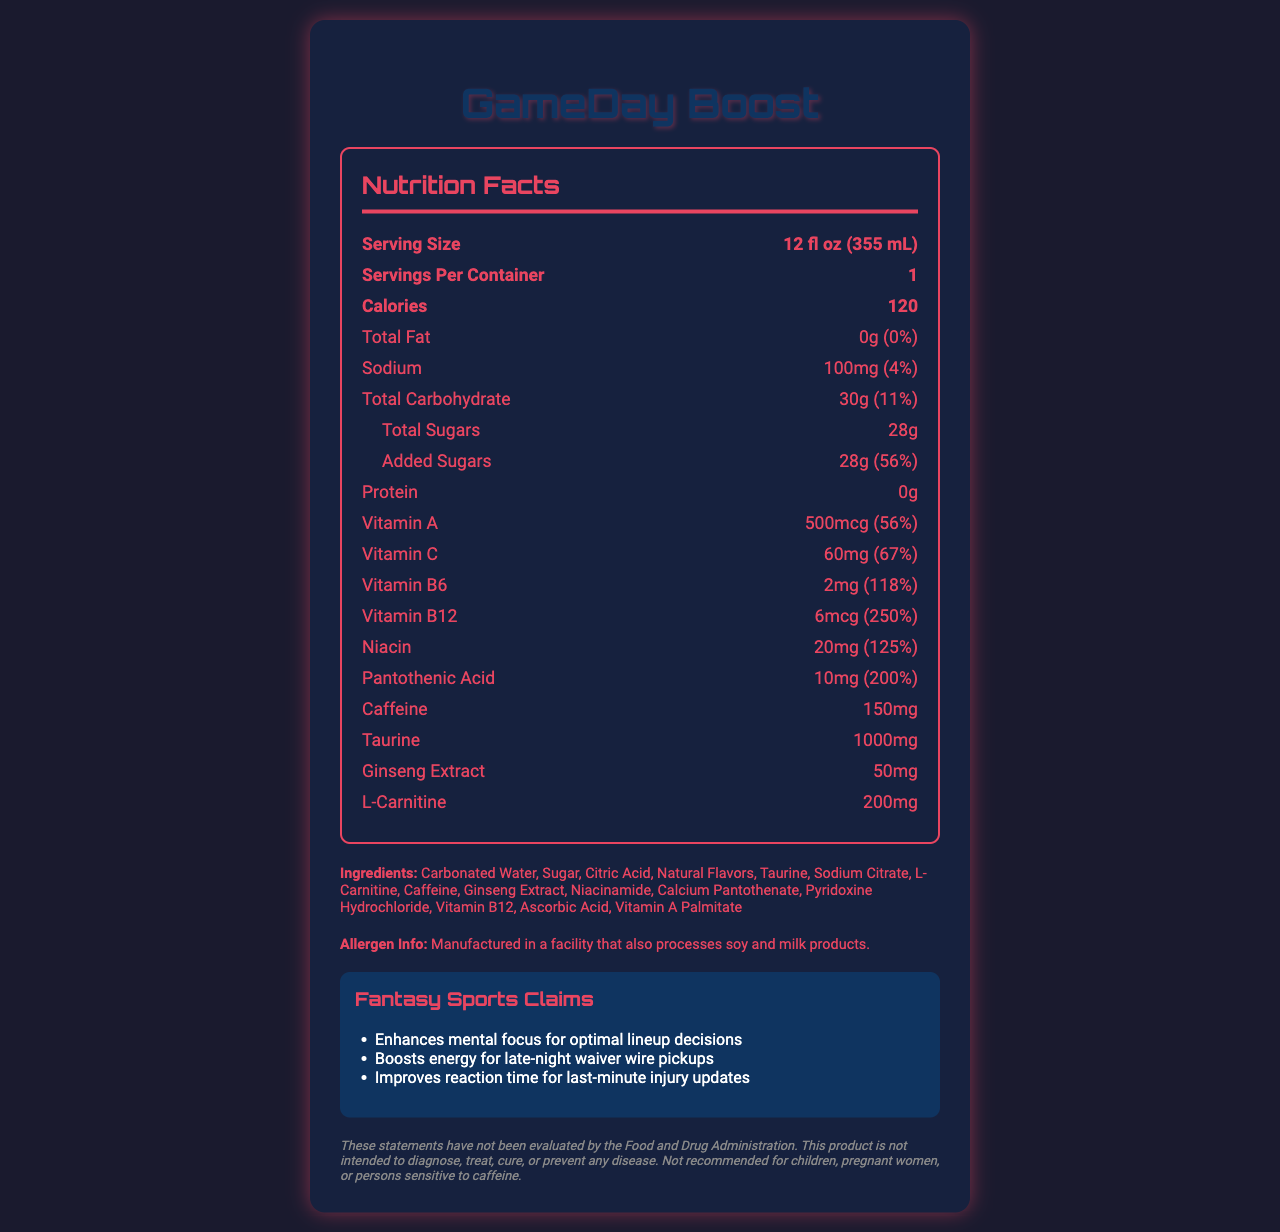who is the product targeted towards? The fantasy sports claims section lists specific benefits tailored for fantasy sports users, such as enhancing mental focus for optimal lineup decisions and boosting energy for late-night waiver wire pickups.
Answer: Fantasy sports enthusiasts what is the serving size of GameDay Boost? The serving size is clearly stated near the beginning of the nutrition facts section.
Answer: 12 fl oz (355 mL) what is the amount of caffeine in one serving of GameDay Boost? The amount of caffeine is listed in the nutrition facts under the section for caffeine.
Answer: 150mg how much Vitamin B12 does one serving contain? The nutrition facts section lists Vitamin B12 content as 6mcg, which is 250% of the daily value.
Answer: 6mcg what is the daily value percentage of niacin in GameDay Boost? The nutrition facts section lists Niacin as containing 125% of the daily value.
Answer: 125% how many grams of added sugars are in one serving? The nutrition facts section lists added sugars as 28g, which is 56% of the daily value.
Answer: 28g which vitamin has the highest percentage daily value in GameDay Boost? A. Vitamin A B. Vitamin C C. Vitamin B6 D. Vitamin B12 The daily value percentage for Vitamin B12 is 250%, which is higher than the other listed vitamins.
Answer: D what allergens does GameDay Boost potentially contain? A. Nuts B. Soy C. Milk The allergen info section states that the product is manufactured in a facility that also processes soy and milk products.
Answer: Soy and Milk is GameDay Boost recommended for children? The disclaimer specifies that the product is not recommended for children.
Answer: No describe the primary purpose and features of GameDay Boost. GameDay Boost is tailored for fantasy sports users with claims aimed at advantages in fantasy sports activities. Nutritional information highlights significant caffeine and sugar content, as well as various vitamins beneficial for energy and focus.
Answer: GameDay Boost is an energy drink designed for fantasy sports enthusiasts, providing nutritional and functional benefits to enhance mental focus, boost energy, and improve reaction time. It contains added vitamins and minerals, such as Vitamin B12 and Vitamin C, and ingredients like caffeine, taurine, and ginseng extract. The drink also has a high amount of added sugars and is manufactured in a facility that processes soy and milk. does GameDay Boost contain any protein? The nutrition facts section clearly shows that the amount of protein is 0g.
Answer: No how does GameDay Boost enhance mental focus? The document claims that GameDay Boost enhances mental focus for optimal lineup decisions but does not provide specific mechanisms or evidence on how it achieves this.
Answer: Cannot be determined 